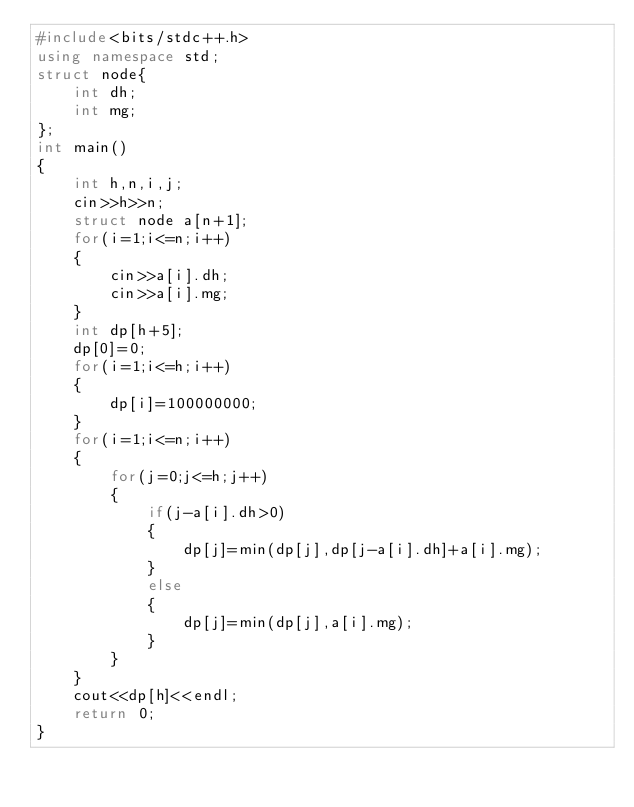Convert code to text. <code><loc_0><loc_0><loc_500><loc_500><_C++_>#include<bits/stdc++.h>
using namespace std;
struct node{
	int dh;
	int mg;
};
int main()
{
	int h,n,i,j;
	cin>>h>>n;
	struct node a[n+1];
	for(i=1;i<=n;i++)
	{
		cin>>a[i].dh;
		cin>>a[i].mg;
	}
	int dp[h+5];
	dp[0]=0;
	for(i=1;i<=h;i++)
	{
		dp[i]=100000000;
	}
	for(i=1;i<=n;i++) 
	{
        for(j=0;j<=h;j++) 
		{
			if(j-a[i].dh>0)
			{
				dp[j]=min(dp[j],dp[j-a[i].dh]+a[i].mg);
			}
			else
			{
				dp[j]=min(dp[j],a[i].mg);
			}
        }
    }
    cout<<dp[h]<<endl;
	return 0;
}</code> 